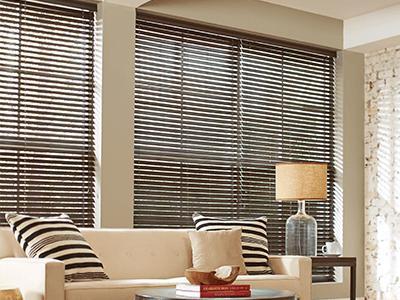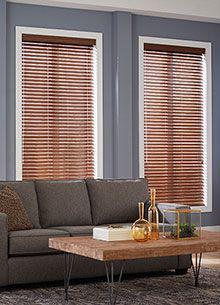The first image is the image on the left, the second image is the image on the right. Considering the images on both sides, is "Some shades are partially up." valid? Answer yes or no. No. The first image is the image on the left, the second image is the image on the right. For the images shown, is this caption "There are six blinds or window coverings." true? Answer yes or no. No. 